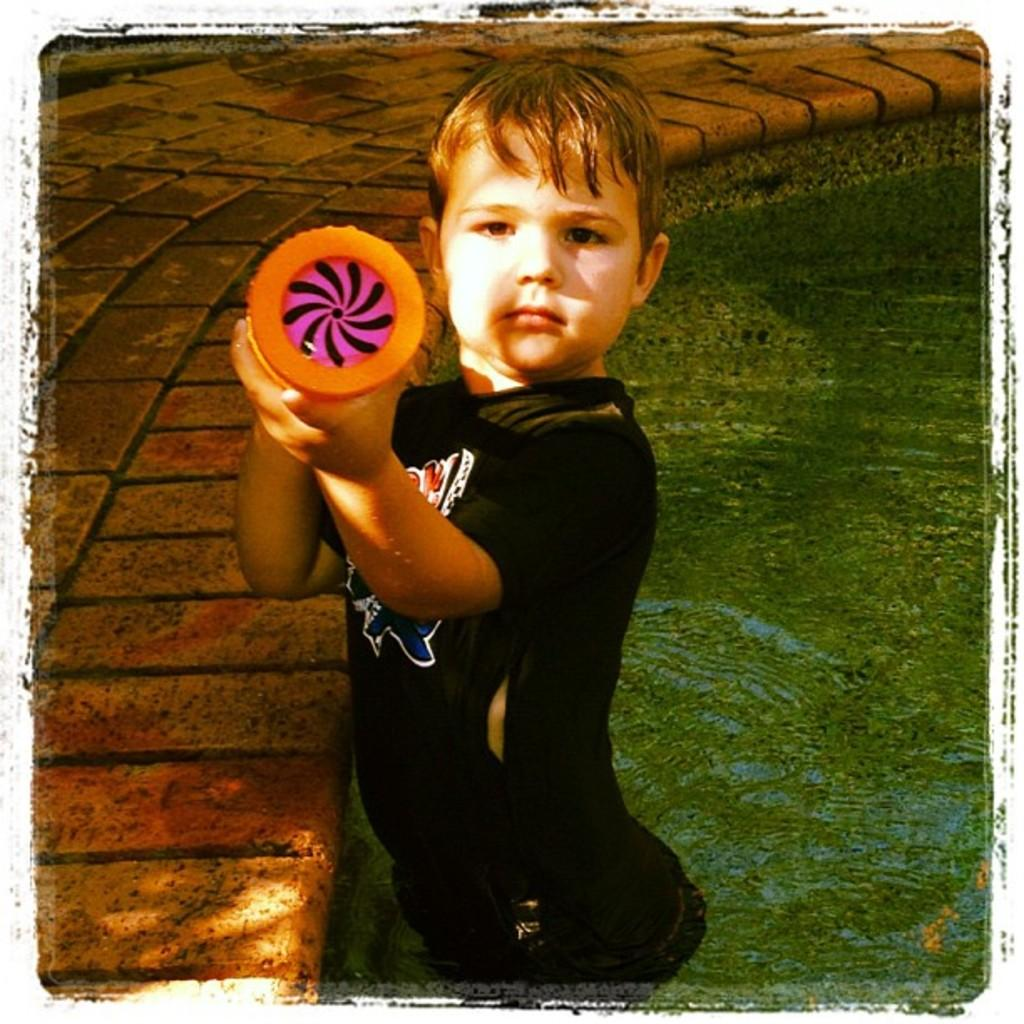Who is present in the image? There is a boy in the image. What is the boy wearing? The boy is wearing a black T-shirt. Where is the boy located in the image? The boy is in the water. What type of lace can be seen on the boy's shoes in the image? There is no mention of shoes or lace in the image, so it cannot be determined if any lace is present. 